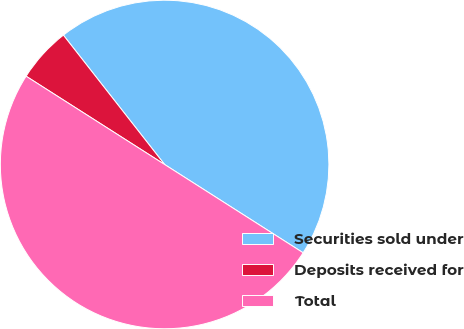Convert chart. <chart><loc_0><loc_0><loc_500><loc_500><pie_chart><fcel>Securities sold under<fcel>Deposits received for<fcel>Total<nl><fcel>44.6%<fcel>5.4%<fcel>50.0%<nl></chart> 